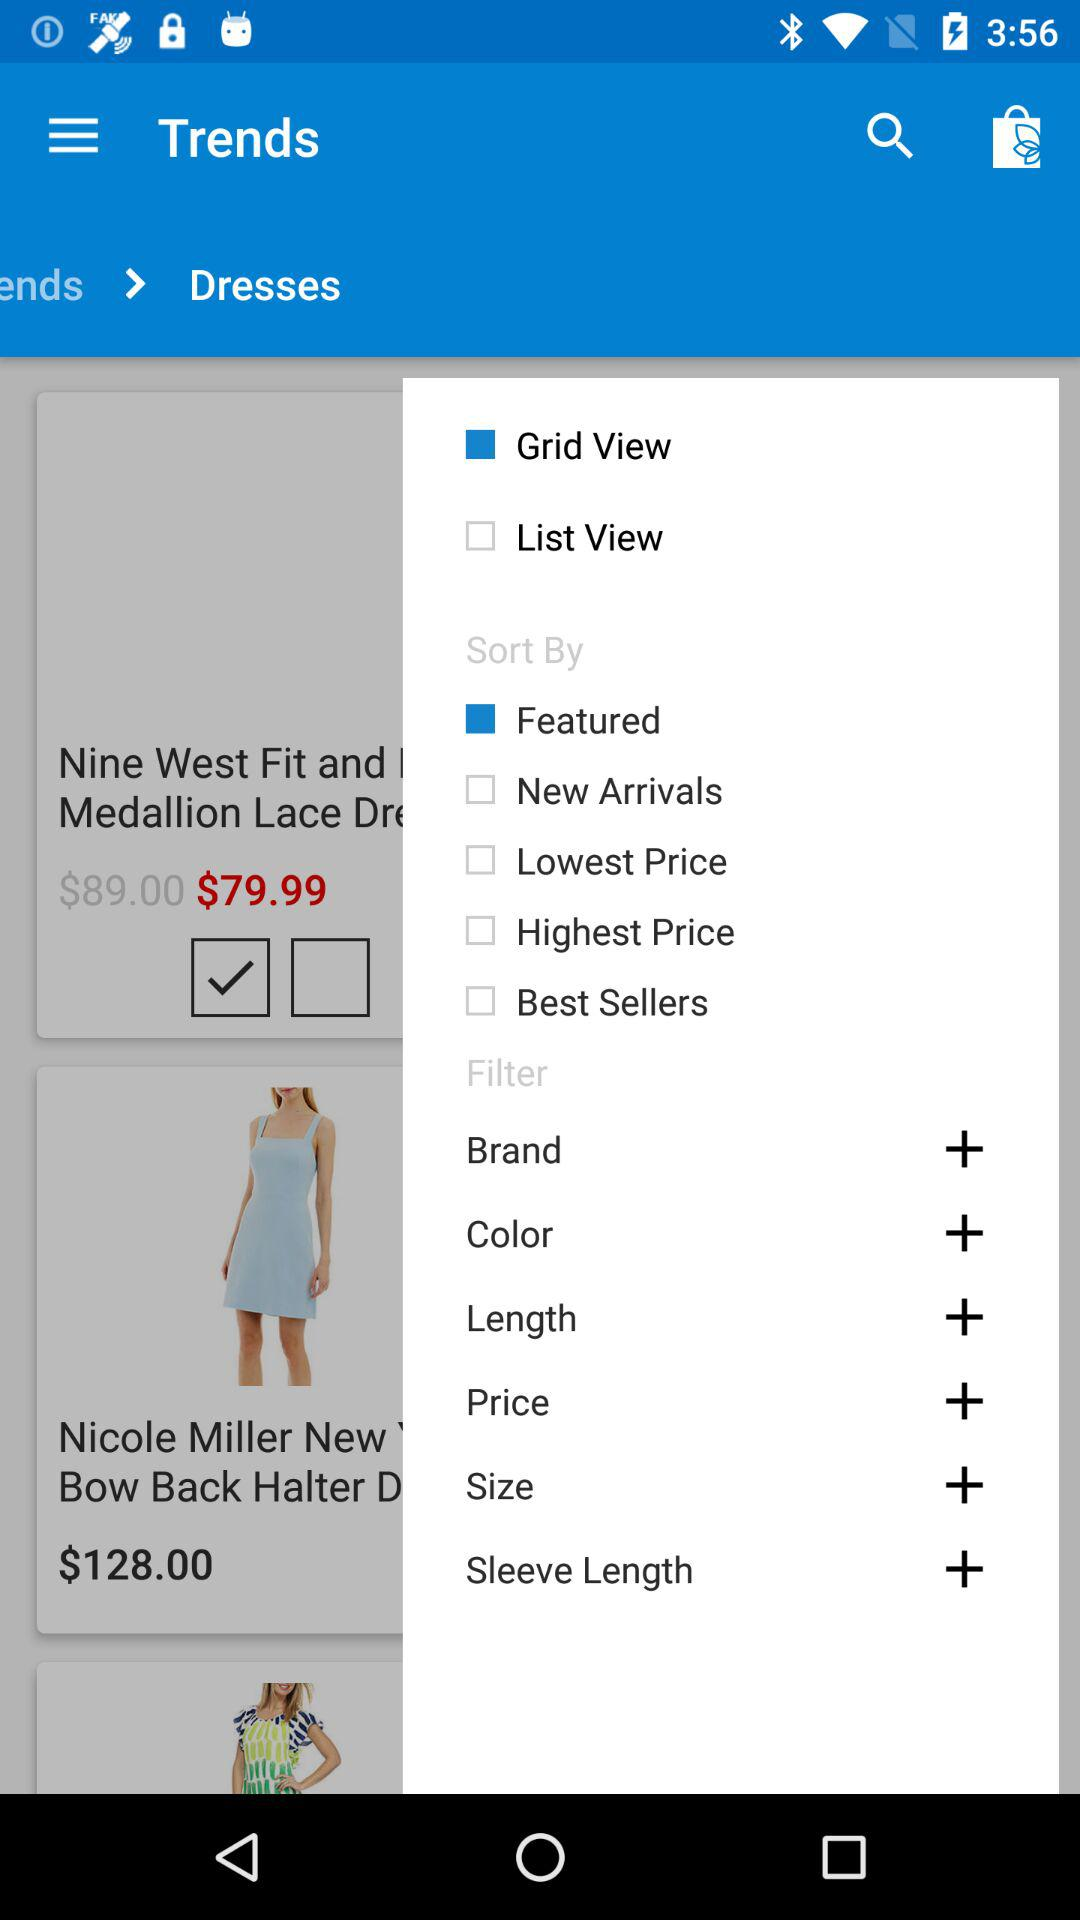What is the cost of Nicole Miller dress? The cost of Nicole Miller dress is $128.00. 